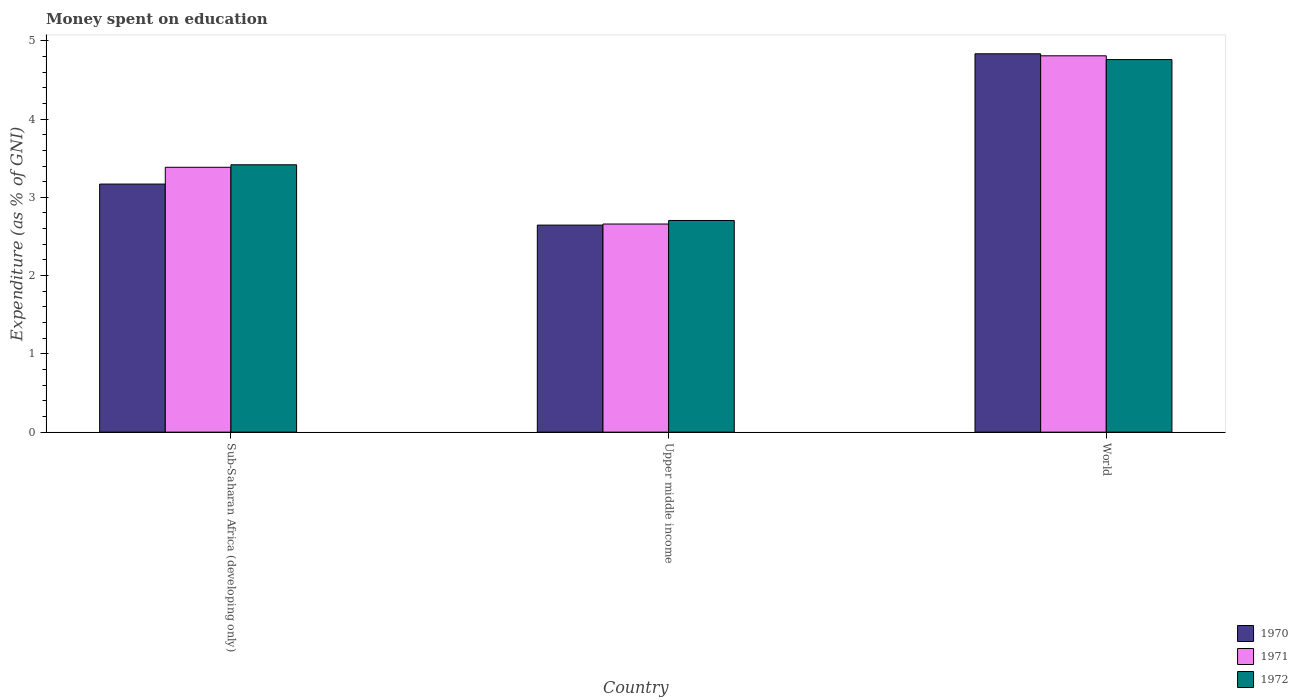How many groups of bars are there?
Ensure brevity in your answer.  3. Are the number of bars per tick equal to the number of legend labels?
Your response must be concise. Yes. Are the number of bars on each tick of the X-axis equal?
Offer a very short reply. Yes. How many bars are there on the 1st tick from the left?
Offer a very short reply. 3. How many bars are there on the 1st tick from the right?
Offer a terse response. 3. What is the label of the 1st group of bars from the left?
Give a very brief answer. Sub-Saharan Africa (developing only). What is the amount of money spent on education in 1970 in Upper middle income?
Provide a succinct answer. 2.65. Across all countries, what is the maximum amount of money spent on education in 1970?
Make the answer very short. 4.83. Across all countries, what is the minimum amount of money spent on education in 1972?
Keep it short and to the point. 2.7. In which country was the amount of money spent on education in 1970 minimum?
Provide a short and direct response. Upper middle income. What is the total amount of money spent on education in 1970 in the graph?
Your answer should be compact. 10.65. What is the difference between the amount of money spent on education in 1970 in Sub-Saharan Africa (developing only) and that in World?
Ensure brevity in your answer.  -1.66. What is the difference between the amount of money spent on education in 1970 in Upper middle income and the amount of money spent on education in 1971 in World?
Ensure brevity in your answer.  -2.16. What is the average amount of money spent on education in 1972 per country?
Your response must be concise. 3.63. What is the difference between the amount of money spent on education of/in 1972 and amount of money spent on education of/in 1971 in World?
Keep it short and to the point. -0.05. What is the ratio of the amount of money spent on education in 1970 in Sub-Saharan Africa (developing only) to that in World?
Give a very brief answer. 0.66. Is the amount of money spent on education in 1970 in Upper middle income less than that in World?
Your response must be concise. Yes. What is the difference between the highest and the second highest amount of money spent on education in 1972?
Provide a short and direct response. -0.71. What is the difference between the highest and the lowest amount of money spent on education in 1970?
Make the answer very short. 2.19. In how many countries, is the amount of money spent on education in 1971 greater than the average amount of money spent on education in 1971 taken over all countries?
Give a very brief answer. 1. Is the sum of the amount of money spent on education in 1971 in Sub-Saharan Africa (developing only) and Upper middle income greater than the maximum amount of money spent on education in 1970 across all countries?
Keep it short and to the point. Yes. What does the 3rd bar from the left in Upper middle income represents?
Offer a terse response. 1972. Is it the case that in every country, the sum of the amount of money spent on education in 1970 and amount of money spent on education in 1971 is greater than the amount of money spent on education in 1972?
Make the answer very short. Yes. Are all the bars in the graph horizontal?
Your answer should be compact. No. How many countries are there in the graph?
Make the answer very short. 3. Are the values on the major ticks of Y-axis written in scientific E-notation?
Your response must be concise. No. Does the graph contain any zero values?
Your answer should be compact. No. How many legend labels are there?
Offer a terse response. 3. What is the title of the graph?
Make the answer very short. Money spent on education. Does "1990" appear as one of the legend labels in the graph?
Provide a succinct answer. No. What is the label or title of the Y-axis?
Give a very brief answer. Expenditure (as % of GNI). What is the Expenditure (as % of GNI) of 1970 in Sub-Saharan Africa (developing only)?
Offer a terse response. 3.17. What is the Expenditure (as % of GNI) in 1971 in Sub-Saharan Africa (developing only)?
Give a very brief answer. 3.38. What is the Expenditure (as % of GNI) of 1972 in Sub-Saharan Africa (developing only)?
Provide a short and direct response. 3.42. What is the Expenditure (as % of GNI) in 1970 in Upper middle income?
Give a very brief answer. 2.65. What is the Expenditure (as % of GNI) in 1971 in Upper middle income?
Provide a short and direct response. 2.66. What is the Expenditure (as % of GNI) in 1972 in Upper middle income?
Offer a very short reply. 2.7. What is the Expenditure (as % of GNI) of 1970 in World?
Your response must be concise. 4.83. What is the Expenditure (as % of GNI) of 1971 in World?
Offer a very short reply. 4.81. What is the Expenditure (as % of GNI) in 1972 in World?
Your answer should be compact. 4.76. Across all countries, what is the maximum Expenditure (as % of GNI) in 1970?
Your answer should be very brief. 4.83. Across all countries, what is the maximum Expenditure (as % of GNI) in 1971?
Offer a terse response. 4.81. Across all countries, what is the maximum Expenditure (as % of GNI) in 1972?
Make the answer very short. 4.76. Across all countries, what is the minimum Expenditure (as % of GNI) in 1970?
Your answer should be compact. 2.65. Across all countries, what is the minimum Expenditure (as % of GNI) in 1971?
Your response must be concise. 2.66. Across all countries, what is the minimum Expenditure (as % of GNI) in 1972?
Make the answer very short. 2.7. What is the total Expenditure (as % of GNI) in 1970 in the graph?
Your answer should be very brief. 10.65. What is the total Expenditure (as % of GNI) in 1971 in the graph?
Your answer should be very brief. 10.85. What is the total Expenditure (as % of GNI) in 1972 in the graph?
Make the answer very short. 10.88. What is the difference between the Expenditure (as % of GNI) of 1970 in Sub-Saharan Africa (developing only) and that in Upper middle income?
Give a very brief answer. 0.52. What is the difference between the Expenditure (as % of GNI) in 1971 in Sub-Saharan Africa (developing only) and that in Upper middle income?
Offer a terse response. 0.72. What is the difference between the Expenditure (as % of GNI) in 1972 in Sub-Saharan Africa (developing only) and that in Upper middle income?
Make the answer very short. 0.71. What is the difference between the Expenditure (as % of GNI) of 1970 in Sub-Saharan Africa (developing only) and that in World?
Keep it short and to the point. -1.66. What is the difference between the Expenditure (as % of GNI) of 1971 in Sub-Saharan Africa (developing only) and that in World?
Provide a succinct answer. -1.42. What is the difference between the Expenditure (as % of GNI) of 1972 in Sub-Saharan Africa (developing only) and that in World?
Offer a very short reply. -1.34. What is the difference between the Expenditure (as % of GNI) of 1970 in Upper middle income and that in World?
Ensure brevity in your answer.  -2.19. What is the difference between the Expenditure (as % of GNI) of 1971 in Upper middle income and that in World?
Offer a very short reply. -2.15. What is the difference between the Expenditure (as % of GNI) of 1972 in Upper middle income and that in World?
Offer a very short reply. -2.06. What is the difference between the Expenditure (as % of GNI) in 1970 in Sub-Saharan Africa (developing only) and the Expenditure (as % of GNI) in 1971 in Upper middle income?
Give a very brief answer. 0.51. What is the difference between the Expenditure (as % of GNI) of 1970 in Sub-Saharan Africa (developing only) and the Expenditure (as % of GNI) of 1972 in Upper middle income?
Ensure brevity in your answer.  0.47. What is the difference between the Expenditure (as % of GNI) of 1971 in Sub-Saharan Africa (developing only) and the Expenditure (as % of GNI) of 1972 in Upper middle income?
Keep it short and to the point. 0.68. What is the difference between the Expenditure (as % of GNI) of 1970 in Sub-Saharan Africa (developing only) and the Expenditure (as % of GNI) of 1971 in World?
Offer a terse response. -1.64. What is the difference between the Expenditure (as % of GNI) in 1970 in Sub-Saharan Africa (developing only) and the Expenditure (as % of GNI) in 1972 in World?
Give a very brief answer. -1.59. What is the difference between the Expenditure (as % of GNI) in 1971 in Sub-Saharan Africa (developing only) and the Expenditure (as % of GNI) in 1972 in World?
Keep it short and to the point. -1.38. What is the difference between the Expenditure (as % of GNI) of 1970 in Upper middle income and the Expenditure (as % of GNI) of 1971 in World?
Offer a very short reply. -2.16. What is the difference between the Expenditure (as % of GNI) in 1970 in Upper middle income and the Expenditure (as % of GNI) in 1972 in World?
Provide a succinct answer. -2.12. What is the difference between the Expenditure (as % of GNI) in 1971 in Upper middle income and the Expenditure (as % of GNI) in 1972 in World?
Ensure brevity in your answer.  -2.1. What is the average Expenditure (as % of GNI) of 1970 per country?
Your response must be concise. 3.55. What is the average Expenditure (as % of GNI) in 1971 per country?
Ensure brevity in your answer.  3.62. What is the average Expenditure (as % of GNI) in 1972 per country?
Ensure brevity in your answer.  3.63. What is the difference between the Expenditure (as % of GNI) in 1970 and Expenditure (as % of GNI) in 1971 in Sub-Saharan Africa (developing only)?
Your response must be concise. -0.21. What is the difference between the Expenditure (as % of GNI) in 1970 and Expenditure (as % of GNI) in 1972 in Sub-Saharan Africa (developing only)?
Offer a very short reply. -0.25. What is the difference between the Expenditure (as % of GNI) of 1971 and Expenditure (as % of GNI) of 1972 in Sub-Saharan Africa (developing only)?
Give a very brief answer. -0.03. What is the difference between the Expenditure (as % of GNI) in 1970 and Expenditure (as % of GNI) in 1971 in Upper middle income?
Make the answer very short. -0.01. What is the difference between the Expenditure (as % of GNI) in 1970 and Expenditure (as % of GNI) in 1972 in Upper middle income?
Offer a very short reply. -0.06. What is the difference between the Expenditure (as % of GNI) in 1971 and Expenditure (as % of GNI) in 1972 in Upper middle income?
Offer a terse response. -0.05. What is the difference between the Expenditure (as % of GNI) in 1970 and Expenditure (as % of GNI) in 1971 in World?
Give a very brief answer. 0.03. What is the difference between the Expenditure (as % of GNI) in 1970 and Expenditure (as % of GNI) in 1972 in World?
Your response must be concise. 0.07. What is the difference between the Expenditure (as % of GNI) in 1971 and Expenditure (as % of GNI) in 1972 in World?
Your answer should be very brief. 0.05. What is the ratio of the Expenditure (as % of GNI) in 1970 in Sub-Saharan Africa (developing only) to that in Upper middle income?
Keep it short and to the point. 1.2. What is the ratio of the Expenditure (as % of GNI) in 1971 in Sub-Saharan Africa (developing only) to that in Upper middle income?
Offer a very short reply. 1.27. What is the ratio of the Expenditure (as % of GNI) of 1972 in Sub-Saharan Africa (developing only) to that in Upper middle income?
Your response must be concise. 1.26. What is the ratio of the Expenditure (as % of GNI) of 1970 in Sub-Saharan Africa (developing only) to that in World?
Offer a terse response. 0.66. What is the ratio of the Expenditure (as % of GNI) in 1971 in Sub-Saharan Africa (developing only) to that in World?
Offer a terse response. 0.7. What is the ratio of the Expenditure (as % of GNI) in 1972 in Sub-Saharan Africa (developing only) to that in World?
Ensure brevity in your answer.  0.72. What is the ratio of the Expenditure (as % of GNI) of 1970 in Upper middle income to that in World?
Provide a short and direct response. 0.55. What is the ratio of the Expenditure (as % of GNI) of 1971 in Upper middle income to that in World?
Ensure brevity in your answer.  0.55. What is the ratio of the Expenditure (as % of GNI) of 1972 in Upper middle income to that in World?
Give a very brief answer. 0.57. What is the difference between the highest and the second highest Expenditure (as % of GNI) in 1970?
Your answer should be compact. 1.66. What is the difference between the highest and the second highest Expenditure (as % of GNI) of 1971?
Give a very brief answer. 1.42. What is the difference between the highest and the second highest Expenditure (as % of GNI) in 1972?
Make the answer very short. 1.34. What is the difference between the highest and the lowest Expenditure (as % of GNI) in 1970?
Keep it short and to the point. 2.19. What is the difference between the highest and the lowest Expenditure (as % of GNI) in 1971?
Your answer should be very brief. 2.15. What is the difference between the highest and the lowest Expenditure (as % of GNI) in 1972?
Keep it short and to the point. 2.06. 